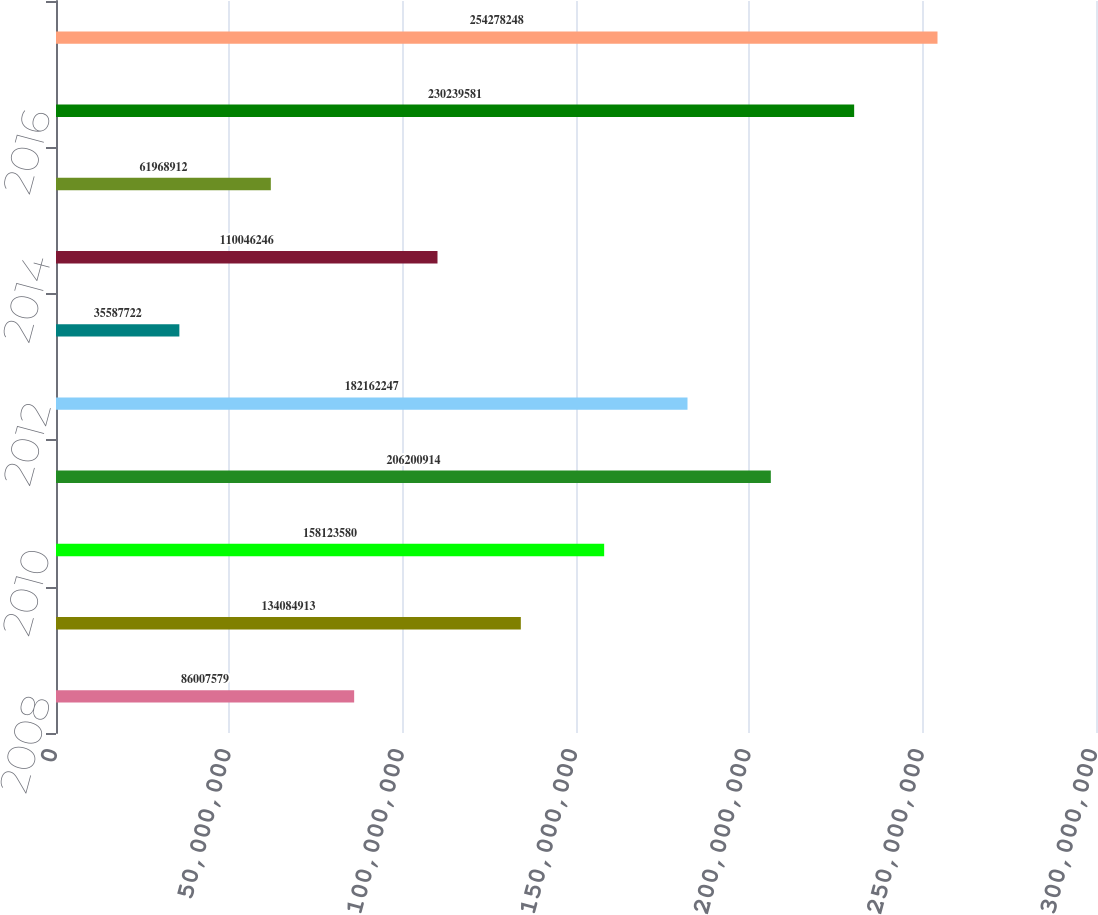Convert chart. <chart><loc_0><loc_0><loc_500><loc_500><bar_chart><fcel>2008<fcel>2009<fcel>2010<fcel>2011<fcel>2012<fcel>2013<fcel>2014<fcel>2015<fcel>2016<fcel>2017<nl><fcel>8.60076e+07<fcel>1.34085e+08<fcel>1.58124e+08<fcel>2.06201e+08<fcel>1.82162e+08<fcel>3.55877e+07<fcel>1.10046e+08<fcel>6.19689e+07<fcel>2.3024e+08<fcel>2.54278e+08<nl></chart> 